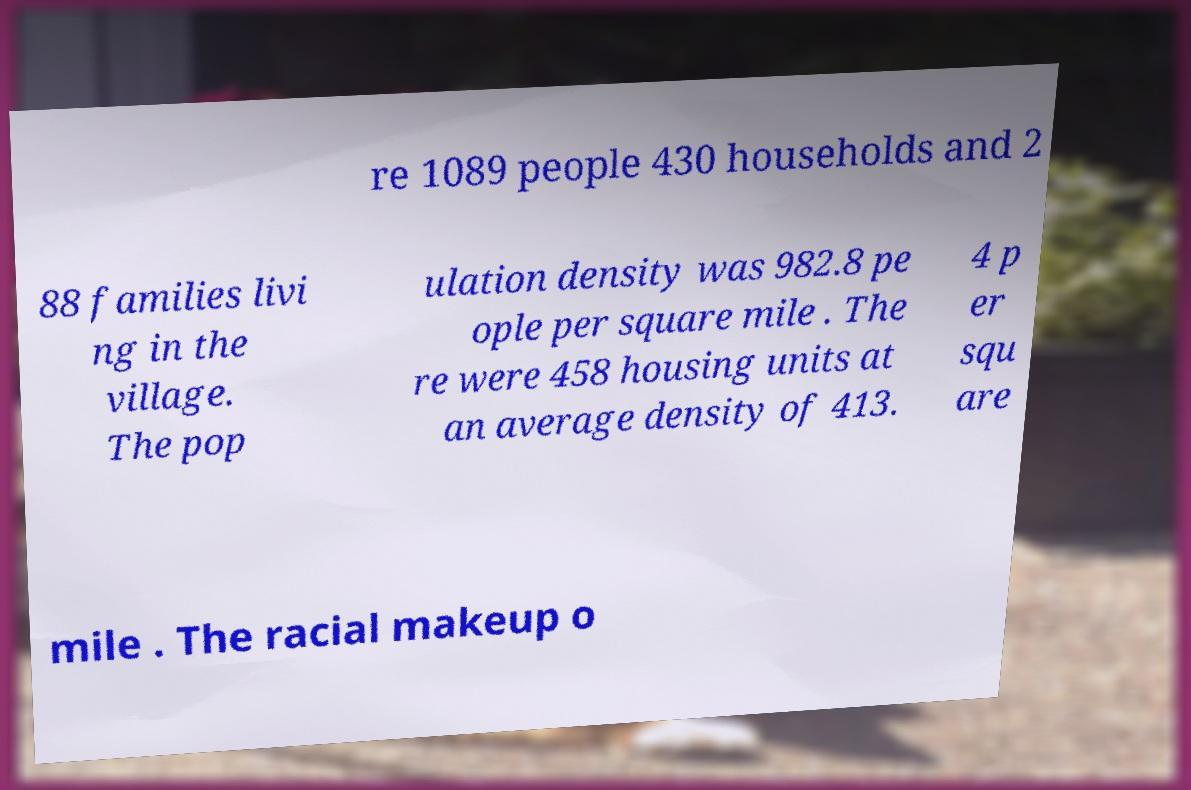I need the written content from this picture converted into text. Can you do that? re 1089 people 430 households and 2 88 families livi ng in the village. The pop ulation density was 982.8 pe ople per square mile . The re were 458 housing units at an average density of 413. 4 p er squ are mile . The racial makeup o 